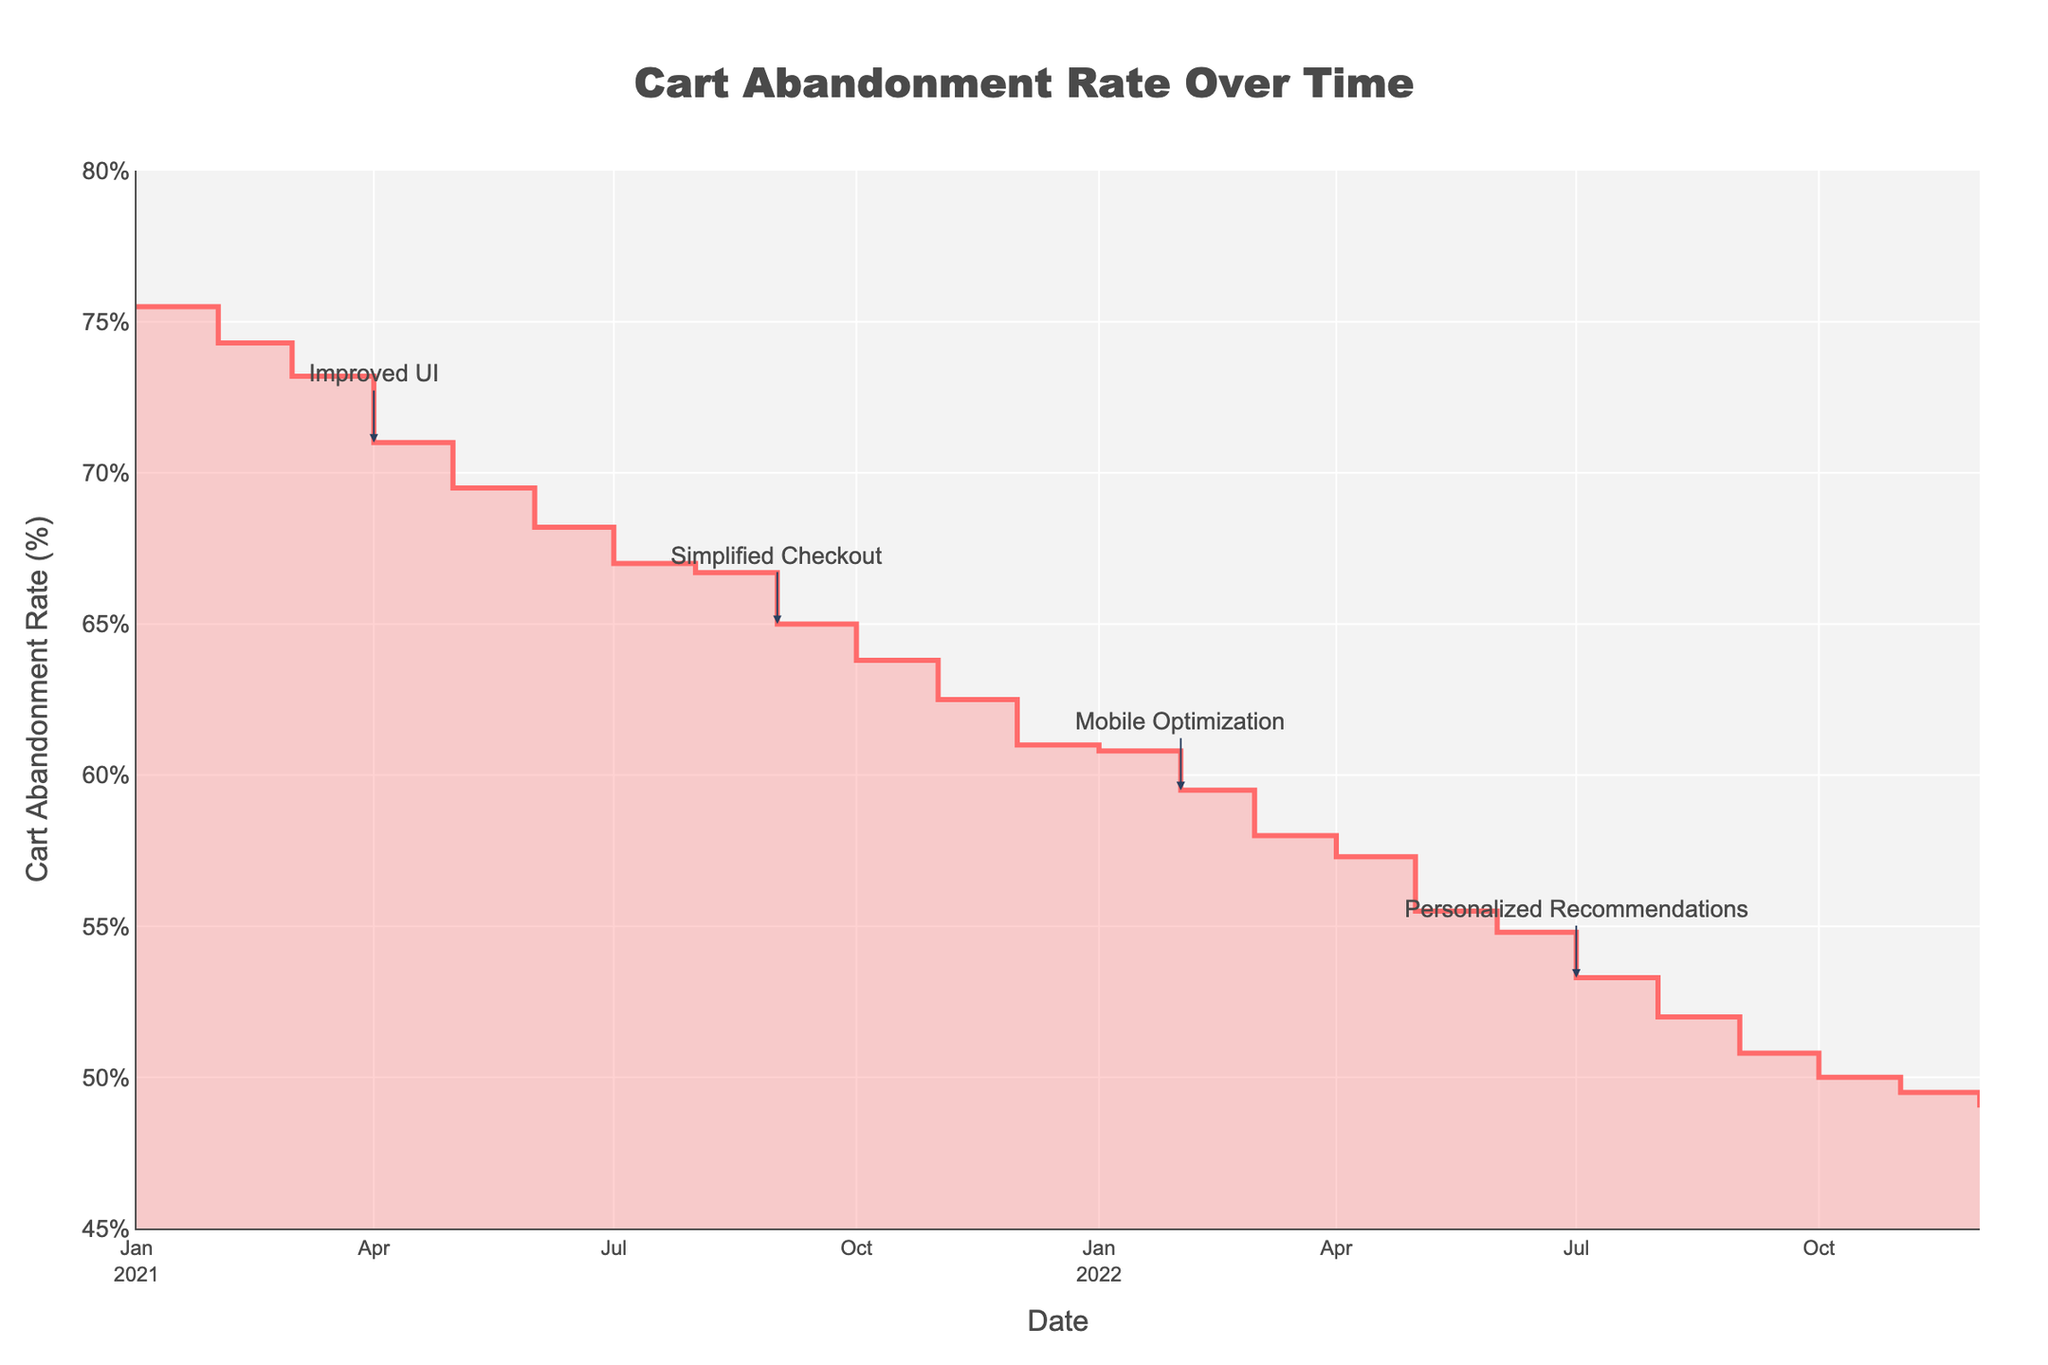What's the title of the chart? The title is located at the top center of the chart. It reads "Cart Abandonment Rate Over Time".
Answer: Cart Abandonment Rate Over Time What does the y-axis represent? The y-axis title indicates what it measures, which can be found on the vertical axis. It is labeled "Cart Abandonment Rate (%)".
Answer: Cart Abandonment Rate (%) How has the cart abandonment rate changed from January 2021 to December 2022? The line on the graph trends downward from January 2021 to December 2022, indicating a decrease in the cart abandonment rate.
Answer: It decreased When was the "Improved UI" implemented, and what was its effect on the cart abandonment rate? The annotation "Improved UI" is marked at April 2021 (2021-04-01), and coinciding with this, the cart abandonment rate shows a noticeable decline afterwards.
Answer: April 2021; It decreased Which online user experience improvement is followed by the largest drop in cart abandonment rate? By examining each annotated improvement and the subsequent drop, "Simplified Checkout" (September 2021) shows a significant drop from 71% in August 2021 to 65% in September 2021.
Answer: Simplified Checkout What is the approximate difference in cart abandonment rate between January 2021 and November 2022? The cart abandonment rate in January 2021 is approximately 75.5%, and in November 2022 it is approximately 49.5%. The difference is calculated as 75.5% - 49.5%.
Answer: 26% Which time period shows the most significant reduction in cart abandonment rate? Between February 2022 (59.5%) and July 2022 (53.3%) the chart indicates a significant and rapid reduction in the cart abandonment rate.
Answer: February 2022 to July 2022 What is the cart abandonment rate at the beginning and end of 2021? At the start of 2021 (January), the cart abandonment rate is around 75.5%. At the end of 2021 (December), it is around 61.0%.
Answer: January 2021: 75.5%, December 2021: 61.0% Explain how the "Mobile Optimization" improvement relates to the change in the cart abandonment rate. The "Mobile Optimization" note on the chart is at February 2022 (59.5%), and following this improvement, there is a consistent decline until July 2022 where it reaches approximately 53.3%.
Answer: It led to a decrease What was the cart abandonment rate before and after "Personalized Recommendations"? The rate was about 53.3% in July 2022 (before the improvement). After July 2022, it continued to decrease, reaching around 50.0% by October 2022 and 49.0% by December 2022.
Answer: Before: 53.3%; After: 49.0% 